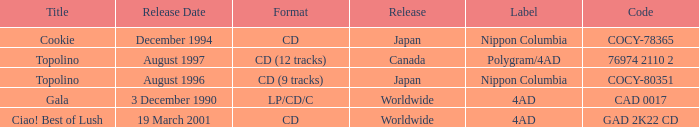What Label released an album in August 1996? Nippon Columbia. 